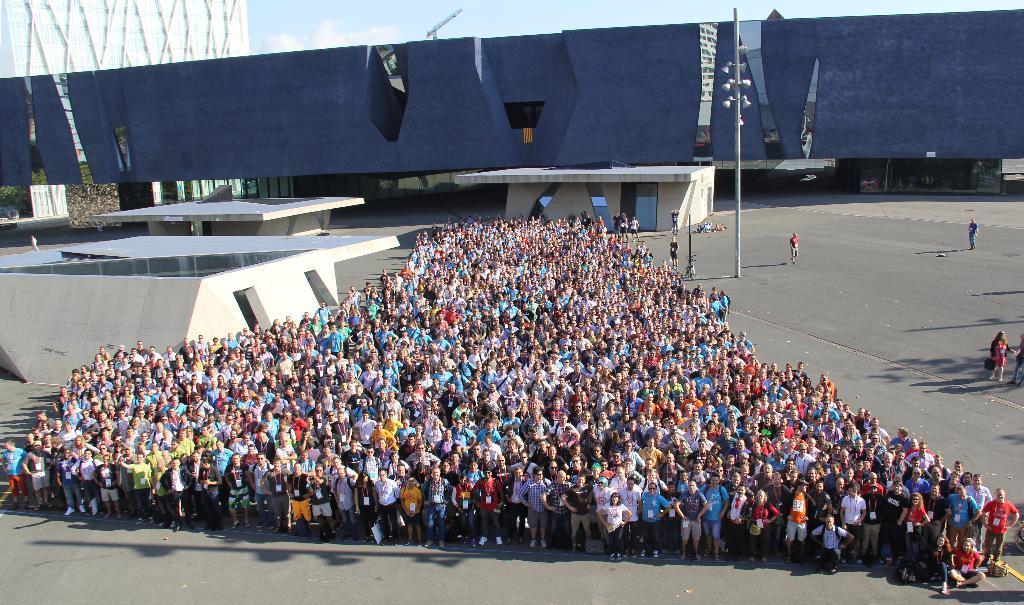How many people are visible in the image? There are many people in the image. What can be seen in the image besides the people? There is a pole in the image. What is visible in the background of the image? There are buildings in the background of the image. How many jellyfish are swimming in the image? There are no jellyfish present in the image. What type of loss is being experienced by the people in the image? There is no indication of any loss being experienced by the people in the image. 